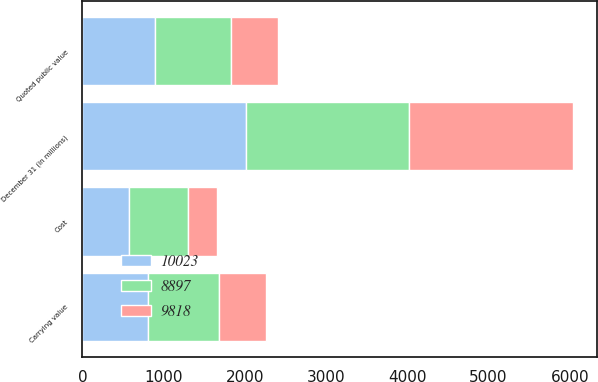Convert chart to OTSL. <chart><loc_0><loc_0><loc_500><loc_500><stacked_bar_chart><ecel><fcel>December 31 (in millions)<fcel>Carrying value<fcel>Cost<fcel>Quoted public value<nl><fcel>9818<fcel>2012<fcel>578<fcel>350<fcel>578<nl><fcel>10023<fcel>2011<fcel>805<fcel>573<fcel>896<nl><fcel>8897<fcel>2010<fcel>875<fcel>732<fcel>935<nl></chart> 